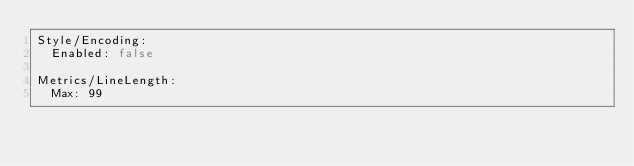<code> <loc_0><loc_0><loc_500><loc_500><_YAML_>Style/Encoding:
  Enabled: false

Metrics/LineLength:
  Max: 99
</code> 